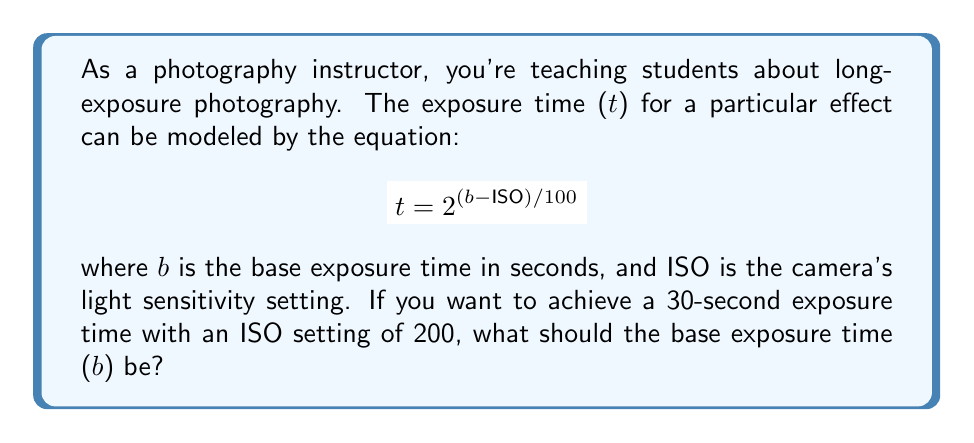Show me your answer to this math problem. To solve this problem, we need to use the given exponential equation and work backwards to find the value of b. Let's approach this step-by-step:

1) We're given the equation: $$ t = 2^{(b-ISO)/100} $$

2) We know that:
   - t = 30 seconds (desired exposure time)
   - ISO = 200

3) Let's substitute these values into the equation:

   $$ 30 = 2^{(b-200)/100} $$

4) To solve for b, we need to apply logarithms to both sides. We'll use log base 2 since the equation is already in base 2:

   $$ \log_2(30) = \frac{b-200}{100} $$

5) Now, let's multiply both sides by 100:

   $$ 100 \log_2(30) = b - 200 $$

6) Add 200 to both sides:

   $$ 100 \log_2(30) + 200 = b $$

7) Calculate the value of $\log_2(30)$:
   
   $\log_2(30) \approx 4.90689$

8) Now we can calculate b:

   $$ b = 100 * 4.90689 + 200 \approx 690.689 $$

Therefore, the base exposure time should be approximately 690.689 seconds.
Answer: The base exposure time (b) should be approximately 690.689 seconds. 